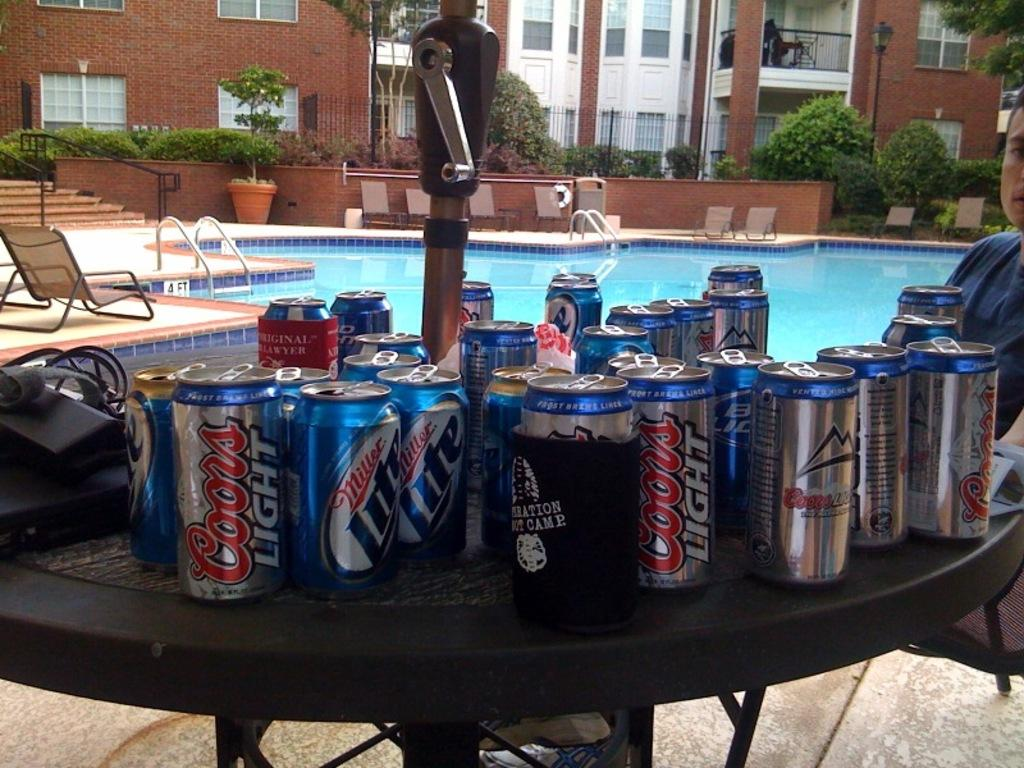<image>
Describe the image concisely. A bunch of cans on a table with labels Coors light and Miller light. 